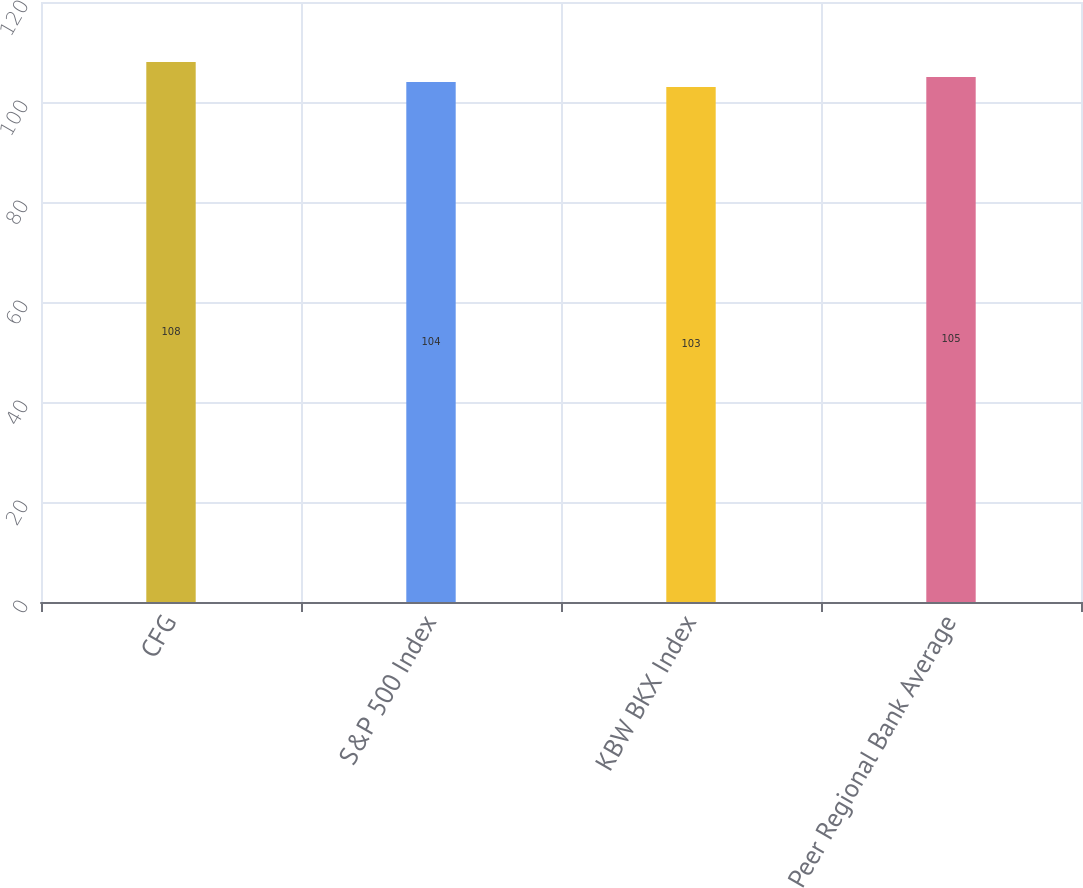Convert chart. <chart><loc_0><loc_0><loc_500><loc_500><bar_chart><fcel>CFG<fcel>S&P 500 Index<fcel>KBW BKX Index<fcel>Peer Regional Bank Average<nl><fcel>108<fcel>104<fcel>103<fcel>105<nl></chart> 